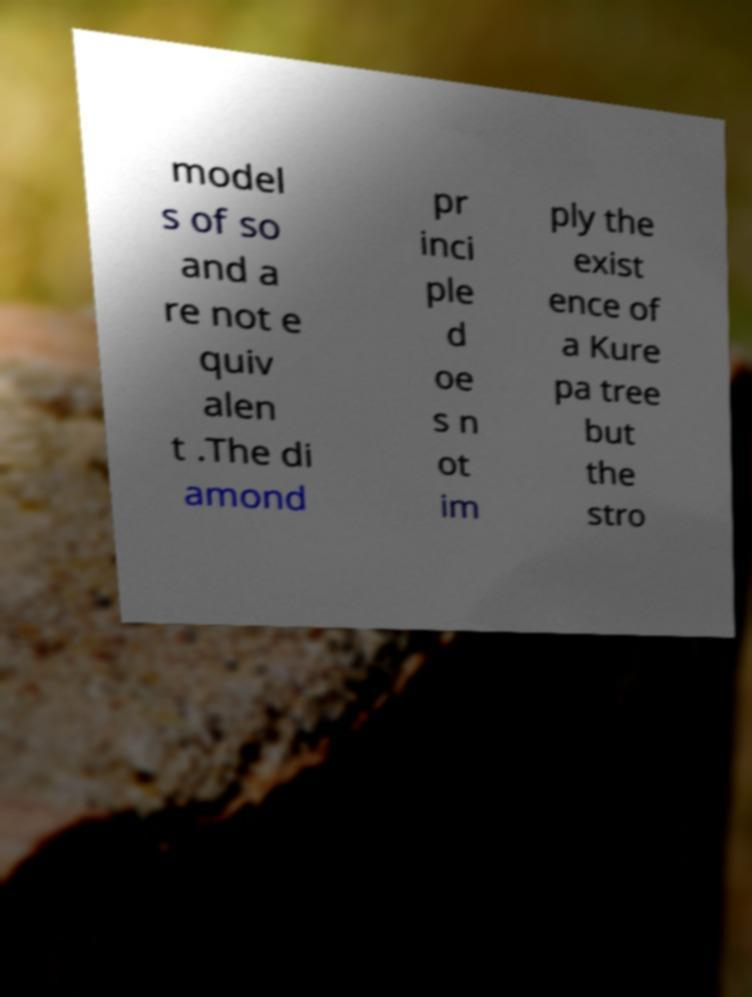Please identify and transcribe the text found in this image. model s of so and a re not e quiv alen t .The di amond pr inci ple d oe s n ot im ply the exist ence of a Kure pa tree but the stro 